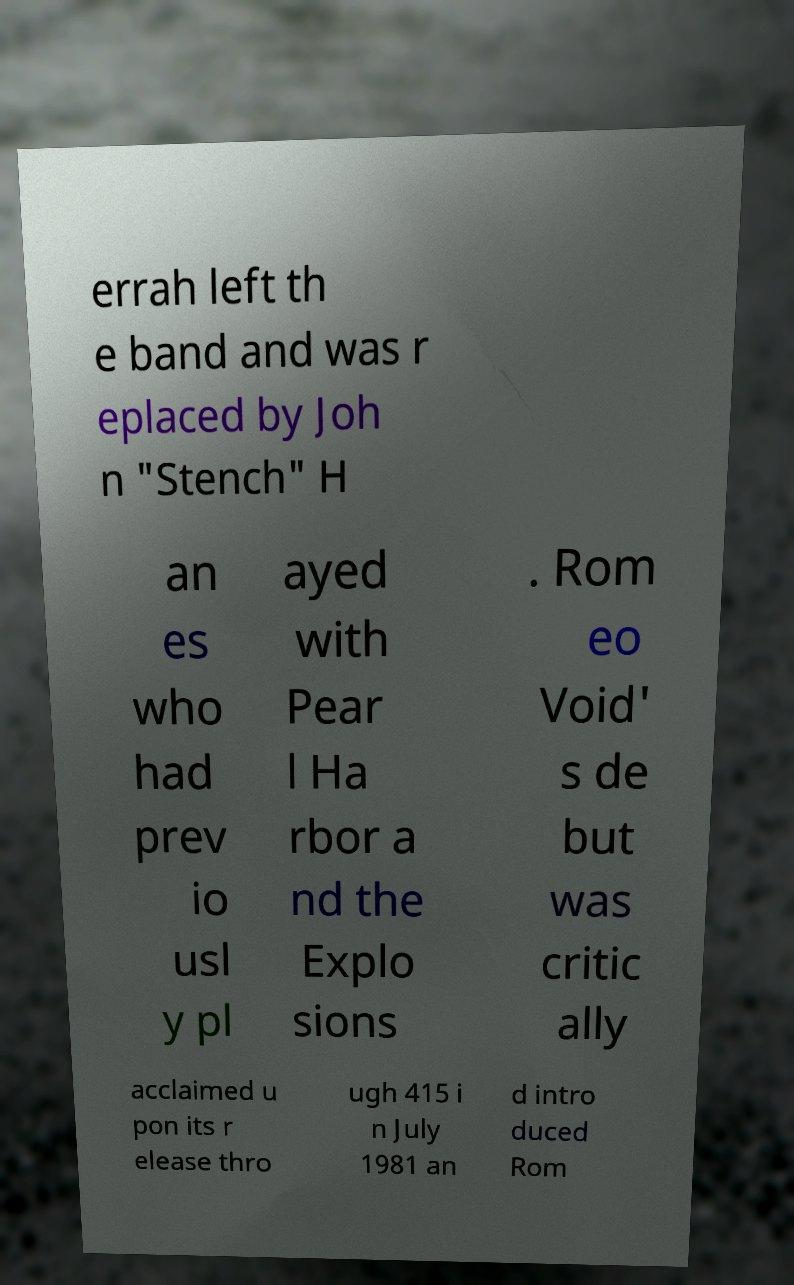Can you read and provide the text displayed in the image?This photo seems to have some interesting text. Can you extract and type it out for me? errah left th e band and was r eplaced by Joh n "Stench" H an es who had prev io usl y pl ayed with Pear l Ha rbor a nd the Explo sions . Rom eo Void' s de but was critic ally acclaimed u pon its r elease thro ugh 415 i n July 1981 an d intro duced Rom 